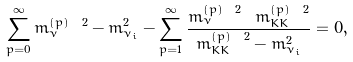Convert formula to latex. <formula><loc_0><loc_0><loc_500><loc_500>\sum _ { p = 0 } ^ { \infty } m _ { \nu } ^ { ( p ) \ 2 } - m ^ { 2 } _ { \nu _ { i } } - \sum _ { p = 1 } ^ { \infty } \frac { m _ { \nu } ^ { ( p ) \ 2 } \ m _ { K K } ^ { ( p ) \ 2 } } { m _ { K K } ^ { ( p ) \ 2 } - m ^ { 2 } _ { \nu _ { i } } } = 0 ,</formula> 